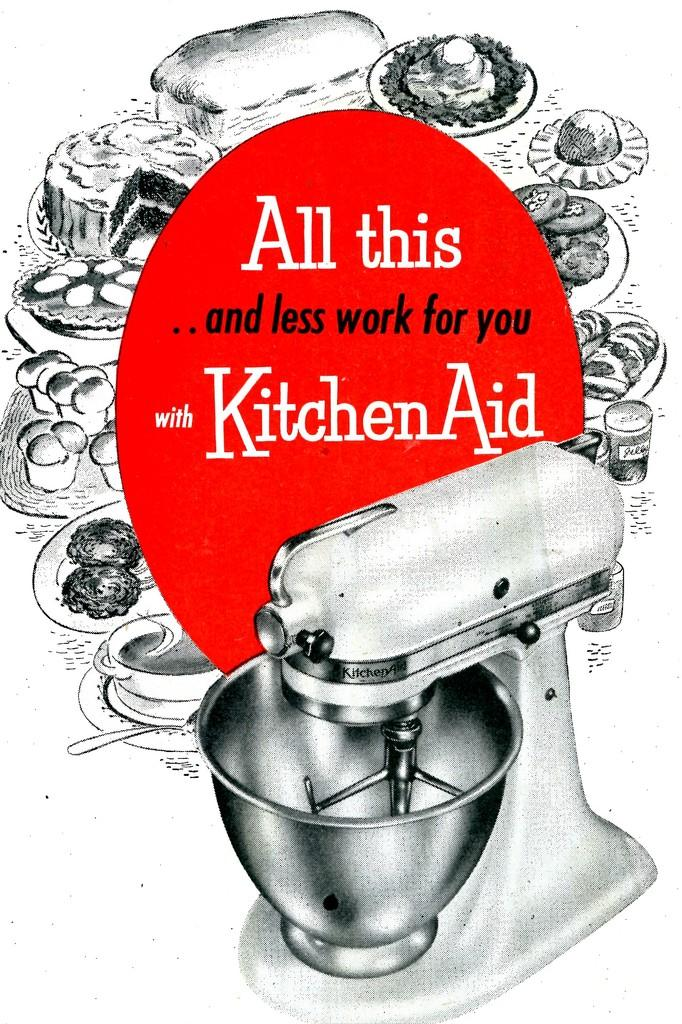<image>
Create a compact narrative representing the image presented. A vintage advertisement of a Kitchen Aid mixer. 